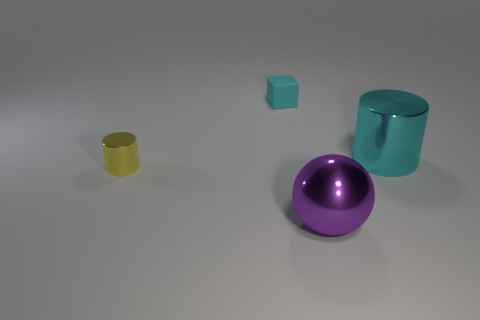Add 2 matte things. How many objects exist? 6 Subtract all blocks. How many objects are left? 3 Subtract 1 blocks. How many blocks are left? 0 Add 2 purple shiny objects. How many purple shiny objects are left? 3 Add 1 tiny cylinders. How many tiny cylinders exist? 2 Subtract 0 blue cylinders. How many objects are left? 4 Subtract all green cylinders. Subtract all gray blocks. How many cylinders are left? 2 Subtract all green spheres. How many purple cubes are left? 0 Subtract all tiny cyan things. Subtract all balls. How many objects are left? 2 